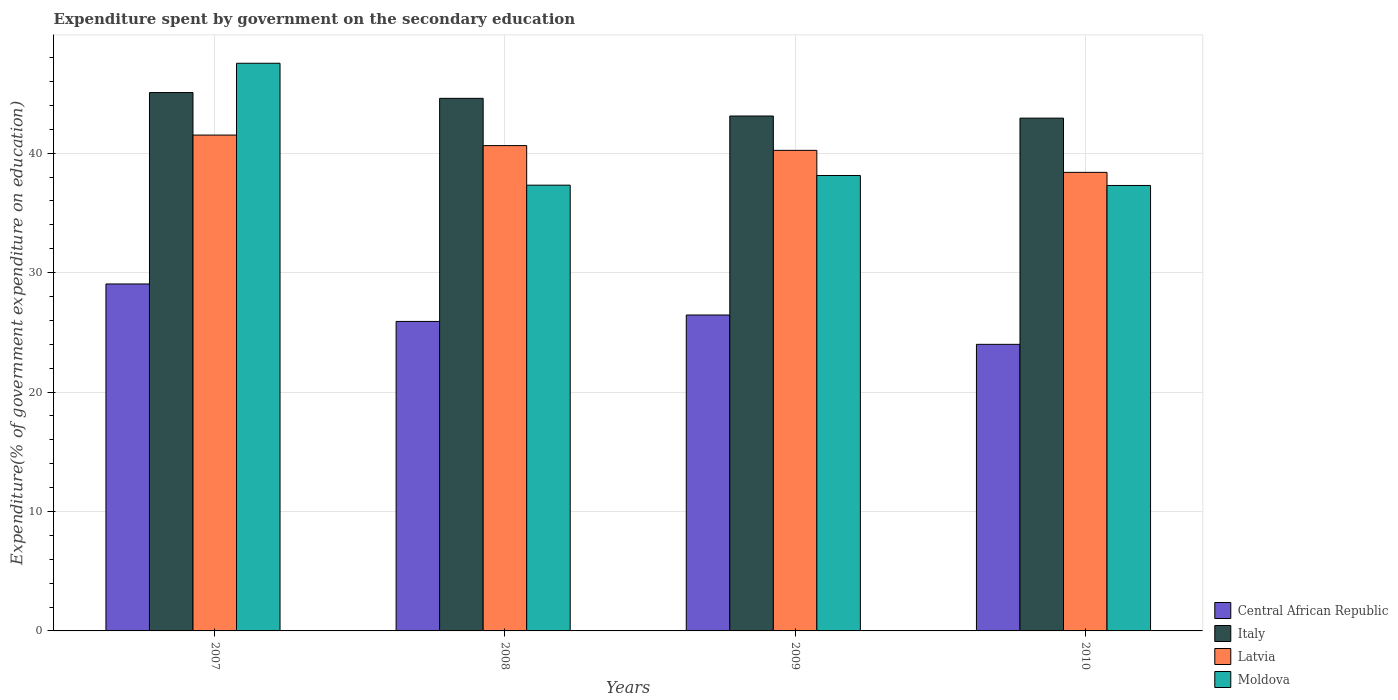How many different coloured bars are there?
Make the answer very short. 4. How many groups of bars are there?
Your answer should be very brief. 4. How many bars are there on the 4th tick from the left?
Your response must be concise. 4. What is the expenditure spent by government on the secondary education in Moldova in 2009?
Your answer should be very brief. 38.13. Across all years, what is the maximum expenditure spent by government on the secondary education in Latvia?
Offer a terse response. 41.52. Across all years, what is the minimum expenditure spent by government on the secondary education in Latvia?
Give a very brief answer. 38.39. In which year was the expenditure spent by government on the secondary education in Central African Republic minimum?
Ensure brevity in your answer.  2010. What is the total expenditure spent by government on the secondary education in Moldova in the graph?
Offer a terse response. 160.28. What is the difference between the expenditure spent by government on the secondary education in Latvia in 2007 and that in 2010?
Keep it short and to the point. 3.12. What is the difference between the expenditure spent by government on the secondary education in Moldova in 2007 and the expenditure spent by government on the secondary education in Central African Republic in 2009?
Give a very brief answer. 21.08. What is the average expenditure spent by government on the secondary education in Latvia per year?
Give a very brief answer. 40.2. In the year 2007, what is the difference between the expenditure spent by government on the secondary education in Central African Republic and expenditure spent by government on the secondary education in Moldova?
Your answer should be compact. -18.48. In how many years, is the expenditure spent by government on the secondary education in Central African Republic greater than 38 %?
Your answer should be very brief. 0. What is the ratio of the expenditure spent by government on the secondary education in Italy in 2007 to that in 2008?
Make the answer very short. 1.01. Is the expenditure spent by government on the secondary education in Latvia in 2007 less than that in 2008?
Ensure brevity in your answer.  No. Is the difference between the expenditure spent by government on the secondary education in Central African Republic in 2007 and 2009 greater than the difference between the expenditure spent by government on the secondary education in Moldova in 2007 and 2009?
Ensure brevity in your answer.  No. What is the difference between the highest and the second highest expenditure spent by government on the secondary education in Central African Republic?
Keep it short and to the point. 2.6. What is the difference between the highest and the lowest expenditure spent by government on the secondary education in Latvia?
Offer a terse response. 3.12. Is it the case that in every year, the sum of the expenditure spent by government on the secondary education in Central African Republic and expenditure spent by government on the secondary education in Italy is greater than the sum of expenditure spent by government on the secondary education in Moldova and expenditure spent by government on the secondary education in Latvia?
Offer a terse response. No. What does the 1st bar from the left in 2010 represents?
Make the answer very short. Central African Republic. What does the 2nd bar from the right in 2008 represents?
Make the answer very short. Latvia. Is it the case that in every year, the sum of the expenditure spent by government on the secondary education in Moldova and expenditure spent by government on the secondary education in Italy is greater than the expenditure spent by government on the secondary education in Latvia?
Offer a very short reply. Yes. How many bars are there?
Your response must be concise. 16. How many years are there in the graph?
Your response must be concise. 4. Are the values on the major ticks of Y-axis written in scientific E-notation?
Give a very brief answer. No. Does the graph contain any zero values?
Your answer should be very brief. No. Where does the legend appear in the graph?
Your answer should be very brief. Bottom right. What is the title of the graph?
Keep it short and to the point. Expenditure spent by government on the secondary education. What is the label or title of the X-axis?
Keep it short and to the point. Years. What is the label or title of the Y-axis?
Your answer should be compact. Expenditure(% of government expenditure on education). What is the Expenditure(% of government expenditure on education) in Central African Republic in 2007?
Give a very brief answer. 29.05. What is the Expenditure(% of government expenditure on education) in Italy in 2007?
Provide a short and direct response. 45.07. What is the Expenditure(% of government expenditure on education) in Latvia in 2007?
Give a very brief answer. 41.52. What is the Expenditure(% of government expenditure on education) in Moldova in 2007?
Keep it short and to the point. 47.53. What is the Expenditure(% of government expenditure on education) of Central African Republic in 2008?
Keep it short and to the point. 25.91. What is the Expenditure(% of government expenditure on education) of Italy in 2008?
Give a very brief answer. 44.59. What is the Expenditure(% of government expenditure on education) in Latvia in 2008?
Your answer should be compact. 40.64. What is the Expenditure(% of government expenditure on education) of Moldova in 2008?
Ensure brevity in your answer.  37.32. What is the Expenditure(% of government expenditure on education) of Central African Republic in 2009?
Keep it short and to the point. 26.45. What is the Expenditure(% of government expenditure on education) of Italy in 2009?
Your answer should be very brief. 43.11. What is the Expenditure(% of government expenditure on education) of Latvia in 2009?
Your answer should be compact. 40.24. What is the Expenditure(% of government expenditure on education) in Moldova in 2009?
Your response must be concise. 38.13. What is the Expenditure(% of government expenditure on education) of Central African Republic in 2010?
Give a very brief answer. 24. What is the Expenditure(% of government expenditure on education) in Italy in 2010?
Provide a short and direct response. 42.94. What is the Expenditure(% of government expenditure on education) of Latvia in 2010?
Provide a short and direct response. 38.39. What is the Expenditure(% of government expenditure on education) in Moldova in 2010?
Give a very brief answer. 37.3. Across all years, what is the maximum Expenditure(% of government expenditure on education) in Central African Republic?
Your answer should be compact. 29.05. Across all years, what is the maximum Expenditure(% of government expenditure on education) in Italy?
Your answer should be very brief. 45.07. Across all years, what is the maximum Expenditure(% of government expenditure on education) of Latvia?
Your answer should be very brief. 41.52. Across all years, what is the maximum Expenditure(% of government expenditure on education) of Moldova?
Provide a succinct answer. 47.53. Across all years, what is the minimum Expenditure(% of government expenditure on education) in Central African Republic?
Keep it short and to the point. 24. Across all years, what is the minimum Expenditure(% of government expenditure on education) of Italy?
Ensure brevity in your answer.  42.94. Across all years, what is the minimum Expenditure(% of government expenditure on education) in Latvia?
Your answer should be very brief. 38.39. Across all years, what is the minimum Expenditure(% of government expenditure on education) in Moldova?
Provide a succinct answer. 37.3. What is the total Expenditure(% of government expenditure on education) in Central African Republic in the graph?
Provide a succinct answer. 105.41. What is the total Expenditure(% of government expenditure on education) in Italy in the graph?
Keep it short and to the point. 175.72. What is the total Expenditure(% of government expenditure on education) of Latvia in the graph?
Your answer should be compact. 160.78. What is the total Expenditure(% of government expenditure on education) of Moldova in the graph?
Provide a succinct answer. 160.28. What is the difference between the Expenditure(% of government expenditure on education) in Central African Republic in 2007 and that in 2008?
Provide a succinct answer. 3.14. What is the difference between the Expenditure(% of government expenditure on education) in Italy in 2007 and that in 2008?
Keep it short and to the point. 0.48. What is the difference between the Expenditure(% of government expenditure on education) of Latvia in 2007 and that in 2008?
Give a very brief answer. 0.88. What is the difference between the Expenditure(% of government expenditure on education) of Moldova in 2007 and that in 2008?
Provide a succinct answer. 10.21. What is the difference between the Expenditure(% of government expenditure on education) in Central African Republic in 2007 and that in 2009?
Keep it short and to the point. 2.6. What is the difference between the Expenditure(% of government expenditure on education) in Italy in 2007 and that in 2009?
Make the answer very short. 1.96. What is the difference between the Expenditure(% of government expenditure on education) of Latvia in 2007 and that in 2009?
Your answer should be compact. 1.28. What is the difference between the Expenditure(% of government expenditure on education) of Moldova in 2007 and that in 2009?
Your answer should be very brief. 9.4. What is the difference between the Expenditure(% of government expenditure on education) in Central African Republic in 2007 and that in 2010?
Your response must be concise. 5.05. What is the difference between the Expenditure(% of government expenditure on education) in Italy in 2007 and that in 2010?
Your response must be concise. 2.14. What is the difference between the Expenditure(% of government expenditure on education) of Latvia in 2007 and that in 2010?
Provide a succinct answer. 3.12. What is the difference between the Expenditure(% of government expenditure on education) of Moldova in 2007 and that in 2010?
Keep it short and to the point. 10.23. What is the difference between the Expenditure(% of government expenditure on education) of Central African Republic in 2008 and that in 2009?
Make the answer very short. -0.54. What is the difference between the Expenditure(% of government expenditure on education) of Italy in 2008 and that in 2009?
Provide a short and direct response. 1.48. What is the difference between the Expenditure(% of government expenditure on education) in Latvia in 2008 and that in 2009?
Your response must be concise. 0.4. What is the difference between the Expenditure(% of government expenditure on education) in Moldova in 2008 and that in 2009?
Your answer should be compact. -0.81. What is the difference between the Expenditure(% of government expenditure on education) of Central African Republic in 2008 and that in 2010?
Ensure brevity in your answer.  1.92. What is the difference between the Expenditure(% of government expenditure on education) of Italy in 2008 and that in 2010?
Keep it short and to the point. 1.66. What is the difference between the Expenditure(% of government expenditure on education) of Latvia in 2008 and that in 2010?
Your response must be concise. 2.24. What is the difference between the Expenditure(% of government expenditure on education) in Moldova in 2008 and that in 2010?
Provide a short and direct response. 0.03. What is the difference between the Expenditure(% of government expenditure on education) in Central African Republic in 2009 and that in 2010?
Ensure brevity in your answer.  2.46. What is the difference between the Expenditure(% of government expenditure on education) in Italy in 2009 and that in 2010?
Ensure brevity in your answer.  0.18. What is the difference between the Expenditure(% of government expenditure on education) in Latvia in 2009 and that in 2010?
Offer a very short reply. 1.84. What is the difference between the Expenditure(% of government expenditure on education) in Moldova in 2009 and that in 2010?
Offer a very short reply. 0.84. What is the difference between the Expenditure(% of government expenditure on education) of Central African Republic in 2007 and the Expenditure(% of government expenditure on education) of Italy in 2008?
Your answer should be compact. -15.54. What is the difference between the Expenditure(% of government expenditure on education) of Central African Republic in 2007 and the Expenditure(% of government expenditure on education) of Latvia in 2008?
Offer a very short reply. -11.59. What is the difference between the Expenditure(% of government expenditure on education) in Central African Republic in 2007 and the Expenditure(% of government expenditure on education) in Moldova in 2008?
Your answer should be very brief. -8.27. What is the difference between the Expenditure(% of government expenditure on education) in Italy in 2007 and the Expenditure(% of government expenditure on education) in Latvia in 2008?
Provide a succinct answer. 4.44. What is the difference between the Expenditure(% of government expenditure on education) of Italy in 2007 and the Expenditure(% of government expenditure on education) of Moldova in 2008?
Ensure brevity in your answer.  7.75. What is the difference between the Expenditure(% of government expenditure on education) of Latvia in 2007 and the Expenditure(% of government expenditure on education) of Moldova in 2008?
Give a very brief answer. 4.19. What is the difference between the Expenditure(% of government expenditure on education) in Central African Republic in 2007 and the Expenditure(% of government expenditure on education) in Italy in 2009?
Your response must be concise. -14.06. What is the difference between the Expenditure(% of government expenditure on education) in Central African Republic in 2007 and the Expenditure(% of government expenditure on education) in Latvia in 2009?
Offer a terse response. -11.19. What is the difference between the Expenditure(% of government expenditure on education) in Central African Republic in 2007 and the Expenditure(% of government expenditure on education) in Moldova in 2009?
Your answer should be very brief. -9.08. What is the difference between the Expenditure(% of government expenditure on education) in Italy in 2007 and the Expenditure(% of government expenditure on education) in Latvia in 2009?
Make the answer very short. 4.84. What is the difference between the Expenditure(% of government expenditure on education) of Italy in 2007 and the Expenditure(% of government expenditure on education) of Moldova in 2009?
Provide a succinct answer. 6.94. What is the difference between the Expenditure(% of government expenditure on education) of Latvia in 2007 and the Expenditure(% of government expenditure on education) of Moldova in 2009?
Your answer should be very brief. 3.38. What is the difference between the Expenditure(% of government expenditure on education) in Central African Republic in 2007 and the Expenditure(% of government expenditure on education) in Italy in 2010?
Offer a very short reply. -13.89. What is the difference between the Expenditure(% of government expenditure on education) of Central African Republic in 2007 and the Expenditure(% of government expenditure on education) of Latvia in 2010?
Make the answer very short. -9.34. What is the difference between the Expenditure(% of government expenditure on education) of Central African Republic in 2007 and the Expenditure(% of government expenditure on education) of Moldova in 2010?
Your answer should be compact. -8.25. What is the difference between the Expenditure(% of government expenditure on education) of Italy in 2007 and the Expenditure(% of government expenditure on education) of Latvia in 2010?
Offer a very short reply. 6.68. What is the difference between the Expenditure(% of government expenditure on education) in Italy in 2007 and the Expenditure(% of government expenditure on education) in Moldova in 2010?
Your answer should be very brief. 7.78. What is the difference between the Expenditure(% of government expenditure on education) of Latvia in 2007 and the Expenditure(% of government expenditure on education) of Moldova in 2010?
Provide a succinct answer. 4.22. What is the difference between the Expenditure(% of government expenditure on education) of Central African Republic in 2008 and the Expenditure(% of government expenditure on education) of Italy in 2009?
Your response must be concise. -17.2. What is the difference between the Expenditure(% of government expenditure on education) of Central African Republic in 2008 and the Expenditure(% of government expenditure on education) of Latvia in 2009?
Offer a very short reply. -14.32. What is the difference between the Expenditure(% of government expenditure on education) in Central African Republic in 2008 and the Expenditure(% of government expenditure on education) in Moldova in 2009?
Offer a very short reply. -12.22. What is the difference between the Expenditure(% of government expenditure on education) in Italy in 2008 and the Expenditure(% of government expenditure on education) in Latvia in 2009?
Your answer should be very brief. 4.36. What is the difference between the Expenditure(% of government expenditure on education) in Italy in 2008 and the Expenditure(% of government expenditure on education) in Moldova in 2009?
Ensure brevity in your answer.  6.46. What is the difference between the Expenditure(% of government expenditure on education) in Latvia in 2008 and the Expenditure(% of government expenditure on education) in Moldova in 2009?
Your response must be concise. 2.5. What is the difference between the Expenditure(% of government expenditure on education) in Central African Republic in 2008 and the Expenditure(% of government expenditure on education) in Italy in 2010?
Provide a short and direct response. -17.02. What is the difference between the Expenditure(% of government expenditure on education) in Central African Republic in 2008 and the Expenditure(% of government expenditure on education) in Latvia in 2010?
Keep it short and to the point. -12.48. What is the difference between the Expenditure(% of government expenditure on education) in Central African Republic in 2008 and the Expenditure(% of government expenditure on education) in Moldova in 2010?
Provide a short and direct response. -11.38. What is the difference between the Expenditure(% of government expenditure on education) of Italy in 2008 and the Expenditure(% of government expenditure on education) of Latvia in 2010?
Offer a terse response. 6.2. What is the difference between the Expenditure(% of government expenditure on education) of Italy in 2008 and the Expenditure(% of government expenditure on education) of Moldova in 2010?
Offer a terse response. 7.3. What is the difference between the Expenditure(% of government expenditure on education) of Latvia in 2008 and the Expenditure(% of government expenditure on education) of Moldova in 2010?
Offer a very short reply. 3.34. What is the difference between the Expenditure(% of government expenditure on education) in Central African Republic in 2009 and the Expenditure(% of government expenditure on education) in Italy in 2010?
Make the answer very short. -16.48. What is the difference between the Expenditure(% of government expenditure on education) of Central African Republic in 2009 and the Expenditure(% of government expenditure on education) of Latvia in 2010?
Ensure brevity in your answer.  -11.94. What is the difference between the Expenditure(% of government expenditure on education) in Central African Republic in 2009 and the Expenditure(% of government expenditure on education) in Moldova in 2010?
Provide a short and direct response. -10.85. What is the difference between the Expenditure(% of government expenditure on education) in Italy in 2009 and the Expenditure(% of government expenditure on education) in Latvia in 2010?
Offer a very short reply. 4.72. What is the difference between the Expenditure(% of government expenditure on education) in Italy in 2009 and the Expenditure(% of government expenditure on education) in Moldova in 2010?
Give a very brief answer. 5.81. What is the difference between the Expenditure(% of government expenditure on education) of Latvia in 2009 and the Expenditure(% of government expenditure on education) of Moldova in 2010?
Provide a short and direct response. 2.94. What is the average Expenditure(% of government expenditure on education) in Central African Republic per year?
Provide a succinct answer. 26.35. What is the average Expenditure(% of government expenditure on education) in Italy per year?
Provide a succinct answer. 43.93. What is the average Expenditure(% of government expenditure on education) in Latvia per year?
Make the answer very short. 40.2. What is the average Expenditure(% of government expenditure on education) in Moldova per year?
Keep it short and to the point. 40.07. In the year 2007, what is the difference between the Expenditure(% of government expenditure on education) of Central African Republic and Expenditure(% of government expenditure on education) of Italy?
Make the answer very short. -16.02. In the year 2007, what is the difference between the Expenditure(% of government expenditure on education) in Central African Republic and Expenditure(% of government expenditure on education) in Latvia?
Keep it short and to the point. -12.47. In the year 2007, what is the difference between the Expenditure(% of government expenditure on education) of Central African Republic and Expenditure(% of government expenditure on education) of Moldova?
Ensure brevity in your answer.  -18.48. In the year 2007, what is the difference between the Expenditure(% of government expenditure on education) in Italy and Expenditure(% of government expenditure on education) in Latvia?
Ensure brevity in your answer.  3.56. In the year 2007, what is the difference between the Expenditure(% of government expenditure on education) of Italy and Expenditure(% of government expenditure on education) of Moldova?
Your answer should be very brief. -2.45. In the year 2007, what is the difference between the Expenditure(% of government expenditure on education) in Latvia and Expenditure(% of government expenditure on education) in Moldova?
Keep it short and to the point. -6.01. In the year 2008, what is the difference between the Expenditure(% of government expenditure on education) in Central African Republic and Expenditure(% of government expenditure on education) in Italy?
Provide a short and direct response. -18.68. In the year 2008, what is the difference between the Expenditure(% of government expenditure on education) in Central African Republic and Expenditure(% of government expenditure on education) in Latvia?
Your answer should be compact. -14.72. In the year 2008, what is the difference between the Expenditure(% of government expenditure on education) of Central African Republic and Expenditure(% of government expenditure on education) of Moldova?
Your response must be concise. -11.41. In the year 2008, what is the difference between the Expenditure(% of government expenditure on education) of Italy and Expenditure(% of government expenditure on education) of Latvia?
Your answer should be compact. 3.96. In the year 2008, what is the difference between the Expenditure(% of government expenditure on education) in Italy and Expenditure(% of government expenditure on education) in Moldova?
Offer a terse response. 7.27. In the year 2008, what is the difference between the Expenditure(% of government expenditure on education) in Latvia and Expenditure(% of government expenditure on education) in Moldova?
Your response must be concise. 3.31. In the year 2009, what is the difference between the Expenditure(% of government expenditure on education) of Central African Republic and Expenditure(% of government expenditure on education) of Italy?
Keep it short and to the point. -16.66. In the year 2009, what is the difference between the Expenditure(% of government expenditure on education) of Central African Republic and Expenditure(% of government expenditure on education) of Latvia?
Your answer should be very brief. -13.79. In the year 2009, what is the difference between the Expenditure(% of government expenditure on education) of Central African Republic and Expenditure(% of government expenditure on education) of Moldova?
Your answer should be very brief. -11.68. In the year 2009, what is the difference between the Expenditure(% of government expenditure on education) of Italy and Expenditure(% of government expenditure on education) of Latvia?
Offer a very short reply. 2.87. In the year 2009, what is the difference between the Expenditure(% of government expenditure on education) of Italy and Expenditure(% of government expenditure on education) of Moldova?
Offer a terse response. 4.98. In the year 2009, what is the difference between the Expenditure(% of government expenditure on education) of Latvia and Expenditure(% of government expenditure on education) of Moldova?
Your answer should be very brief. 2.1. In the year 2010, what is the difference between the Expenditure(% of government expenditure on education) in Central African Republic and Expenditure(% of government expenditure on education) in Italy?
Your response must be concise. -18.94. In the year 2010, what is the difference between the Expenditure(% of government expenditure on education) of Central African Republic and Expenditure(% of government expenditure on education) of Latvia?
Make the answer very short. -14.4. In the year 2010, what is the difference between the Expenditure(% of government expenditure on education) of Central African Republic and Expenditure(% of government expenditure on education) of Moldova?
Ensure brevity in your answer.  -13.3. In the year 2010, what is the difference between the Expenditure(% of government expenditure on education) in Italy and Expenditure(% of government expenditure on education) in Latvia?
Offer a terse response. 4.54. In the year 2010, what is the difference between the Expenditure(% of government expenditure on education) in Italy and Expenditure(% of government expenditure on education) in Moldova?
Provide a succinct answer. 5.64. In the year 2010, what is the difference between the Expenditure(% of government expenditure on education) of Latvia and Expenditure(% of government expenditure on education) of Moldova?
Provide a succinct answer. 1.1. What is the ratio of the Expenditure(% of government expenditure on education) of Central African Republic in 2007 to that in 2008?
Give a very brief answer. 1.12. What is the ratio of the Expenditure(% of government expenditure on education) of Italy in 2007 to that in 2008?
Give a very brief answer. 1.01. What is the ratio of the Expenditure(% of government expenditure on education) in Latvia in 2007 to that in 2008?
Offer a terse response. 1.02. What is the ratio of the Expenditure(% of government expenditure on education) of Moldova in 2007 to that in 2008?
Provide a succinct answer. 1.27. What is the ratio of the Expenditure(% of government expenditure on education) in Central African Republic in 2007 to that in 2009?
Ensure brevity in your answer.  1.1. What is the ratio of the Expenditure(% of government expenditure on education) in Italy in 2007 to that in 2009?
Offer a very short reply. 1.05. What is the ratio of the Expenditure(% of government expenditure on education) of Latvia in 2007 to that in 2009?
Ensure brevity in your answer.  1.03. What is the ratio of the Expenditure(% of government expenditure on education) in Moldova in 2007 to that in 2009?
Offer a very short reply. 1.25. What is the ratio of the Expenditure(% of government expenditure on education) of Central African Republic in 2007 to that in 2010?
Ensure brevity in your answer.  1.21. What is the ratio of the Expenditure(% of government expenditure on education) of Italy in 2007 to that in 2010?
Keep it short and to the point. 1.05. What is the ratio of the Expenditure(% of government expenditure on education) in Latvia in 2007 to that in 2010?
Make the answer very short. 1.08. What is the ratio of the Expenditure(% of government expenditure on education) in Moldova in 2007 to that in 2010?
Make the answer very short. 1.27. What is the ratio of the Expenditure(% of government expenditure on education) of Central African Republic in 2008 to that in 2009?
Offer a very short reply. 0.98. What is the ratio of the Expenditure(% of government expenditure on education) of Italy in 2008 to that in 2009?
Ensure brevity in your answer.  1.03. What is the ratio of the Expenditure(% of government expenditure on education) of Latvia in 2008 to that in 2009?
Offer a very short reply. 1.01. What is the ratio of the Expenditure(% of government expenditure on education) in Moldova in 2008 to that in 2009?
Ensure brevity in your answer.  0.98. What is the ratio of the Expenditure(% of government expenditure on education) of Central African Republic in 2008 to that in 2010?
Ensure brevity in your answer.  1.08. What is the ratio of the Expenditure(% of government expenditure on education) in Italy in 2008 to that in 2010?
Give a very brief answer. 1.04. What is the ratio of the Expenditure(% of government expenditure on education) of Latvia in 2008 to that in 2010?
Make the answer very short. 1.06. What is the ratio of the Expenditure(% of government expenditure on education) of Moldova in 2008 to that in 2010?
Offer a terse response. 1. What is the ratio of the Expenditure(% of government expenditure on education) in Central African Republic in 2009 to that in 2010?
Provide a short and direct response. 1.1. What is the ratio of the Expenditure(% of government expenditure on education) in Italy in 2009 to that in 2010?
Offer a very short reply. 1. What is the ratio of the Expenditure(% of government expenditure on education) of Latvia in 2009 to that in 2010?
Keep it short and to the point. 1.05. What is the ratio of the Expenditure(% of government expenditure on education) in Moldova in 2009 to that in 2010?
Provide a short and direct response. 1.02. What is the difference between the highest and the second highest Expenditure(% of government expenditure on education) in Central African Republic?
Make the answer very short. 2.6. What is the difference between the highest and the second highest Expenditure(% of government expenditure on education) in Italy?
Offer a very short reply. 0.48. What is the difference between the highest and the second highest Expenditure(% of government expenditure on education) of Latvia?
Your response must be concise. 0.88. What is the difference between the highest and the second highest Expenditure(% of government expenditure on education) in Moldova?
Offer a terse response. 9.4. What is the difference between the highest and the lowest Expenditure(% of government expenditure on education) in Central African Republic?
Provide a succinct answer. 5.05. What is the difference between the highest and the lowest Expenditure(% of government expenditure on education) of Italy?
Ensure brevity in your answer.  2.14. What is the difference between the highest and the lowest Expenditure(% of government expenditure on education) of Latvia?
Provide a short and direct response. 3.12. What is the difference between the highest and the lowest Expenditure(% of government expenditure on education) of Moldova?
Offer a terse response. 10.23. 